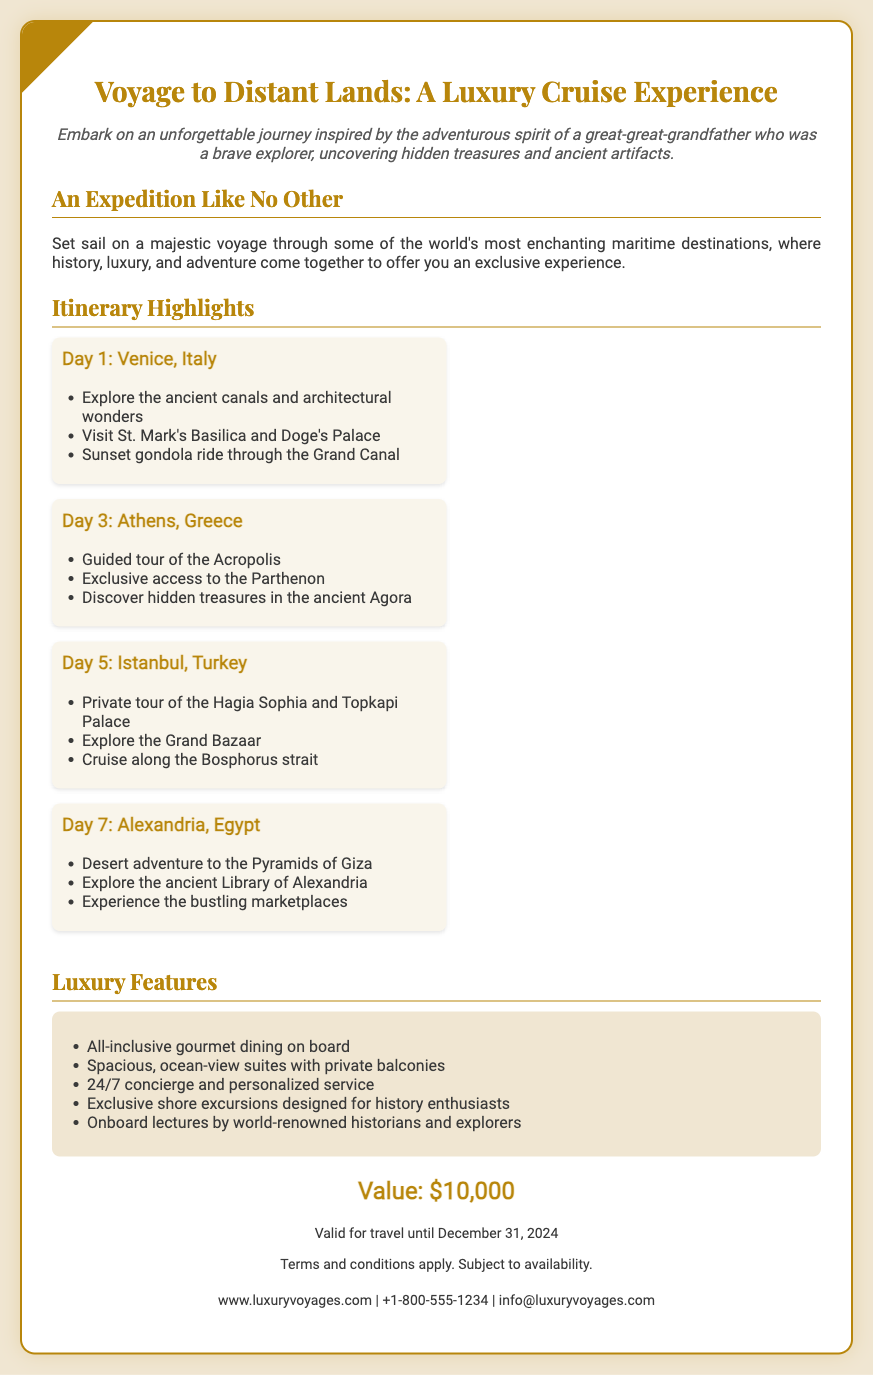What is the title of the voucher? The title is prominently displayed at the top of the document.
Answer: Voyage to Distant Lands: A Luxury Cruise Experience What is the total value of the voucher? The value is highlighted in a specific section of the document.
Answer: $10,000 When is the voucher valid until? The validity date is mentioned in the voucher details at the bottom.
Answer: December 31, 2024 What city is the first destination on the itinerary? The first destination is listed in the itinerary section.
Answer: Venice, Italy What type of tours are included in the luxury features? The luxury features specify the types of experiences offered on the cruise.
Answer: Exclusive shore excursions How many days are mentioned in the itinerary? The document outlines a total of four distinct days in the itinerary.
Answer: Four What notable ancient site is featured in Athens? The itinerary specifies a key historical landmark to be visited.
Answer: Acropolis Which city features a desert adventure in the itinerary? The itinerary highlights Alexandria for its adventurous offerings.
Answer: Alexandria, Egypt Who can be contacted for more information? The contact information section provides details for inquiries.
Answer: info@luxuryvoyages.com 